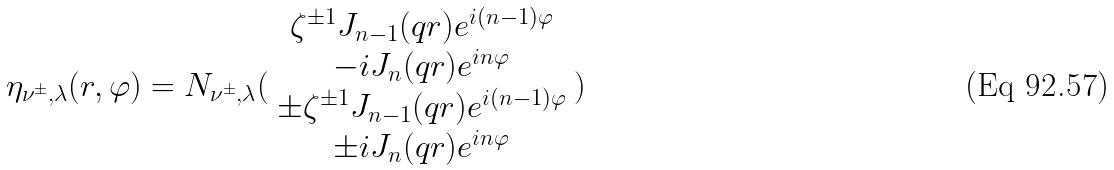Convert formula to latex. <formula><loc_0><loc_0><loc_500><loc_500>\eta _ { \nu ^ { \pm } , \lambda } ( r , \varphi ) = N _ { \nu ^ { \pm } , \lambda } ( \begin{array} { c } \zeta ^ { \pm 1 } J _ { n - 1 } ( q r ) e ^ { i ( n - 1 ) \varphi } \\ - i J _ { n } ( q r ) e ^ { i n \varphi } \\ \pm \zeta ^ { \pm 1 } J _ { n - 1 } ( q r ) e ^ { i ( n - 1 ) \varphi } \\ \pm i J _ { n } ( q r ) e ^ { i n \varphi } \end{array} )</formula> 